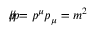<formula> <loc_0><loc_0><loc_500><loc_500>{ p \, / } { p \, / } = p ^ { \mu } p _ { \mu } = m ^ { 2 }</formula> 